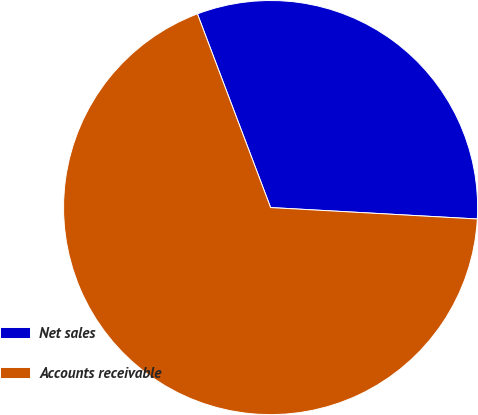<chart> <loc_0><loc_0><loc_500><loc_500><pie_chart><fcel>Net sales<fcel>Accounts receivable<nl><fcel>31.63%<fcel>68.37%<nl></chart> 